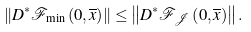Convert formula to latex. <formula><loc_0><loc_0><loc_500><loc_500>\left \| D ^ { \ast } \mathcal { F } _ { \min } \left ( 0 , \overline { x } \right ) \right \| \leq \left \| D ^ { \ast } \mathcal { F } _ { \mathcal { J } } \left ( 0 , \overline { x } \right ) \right \| .</formula> 